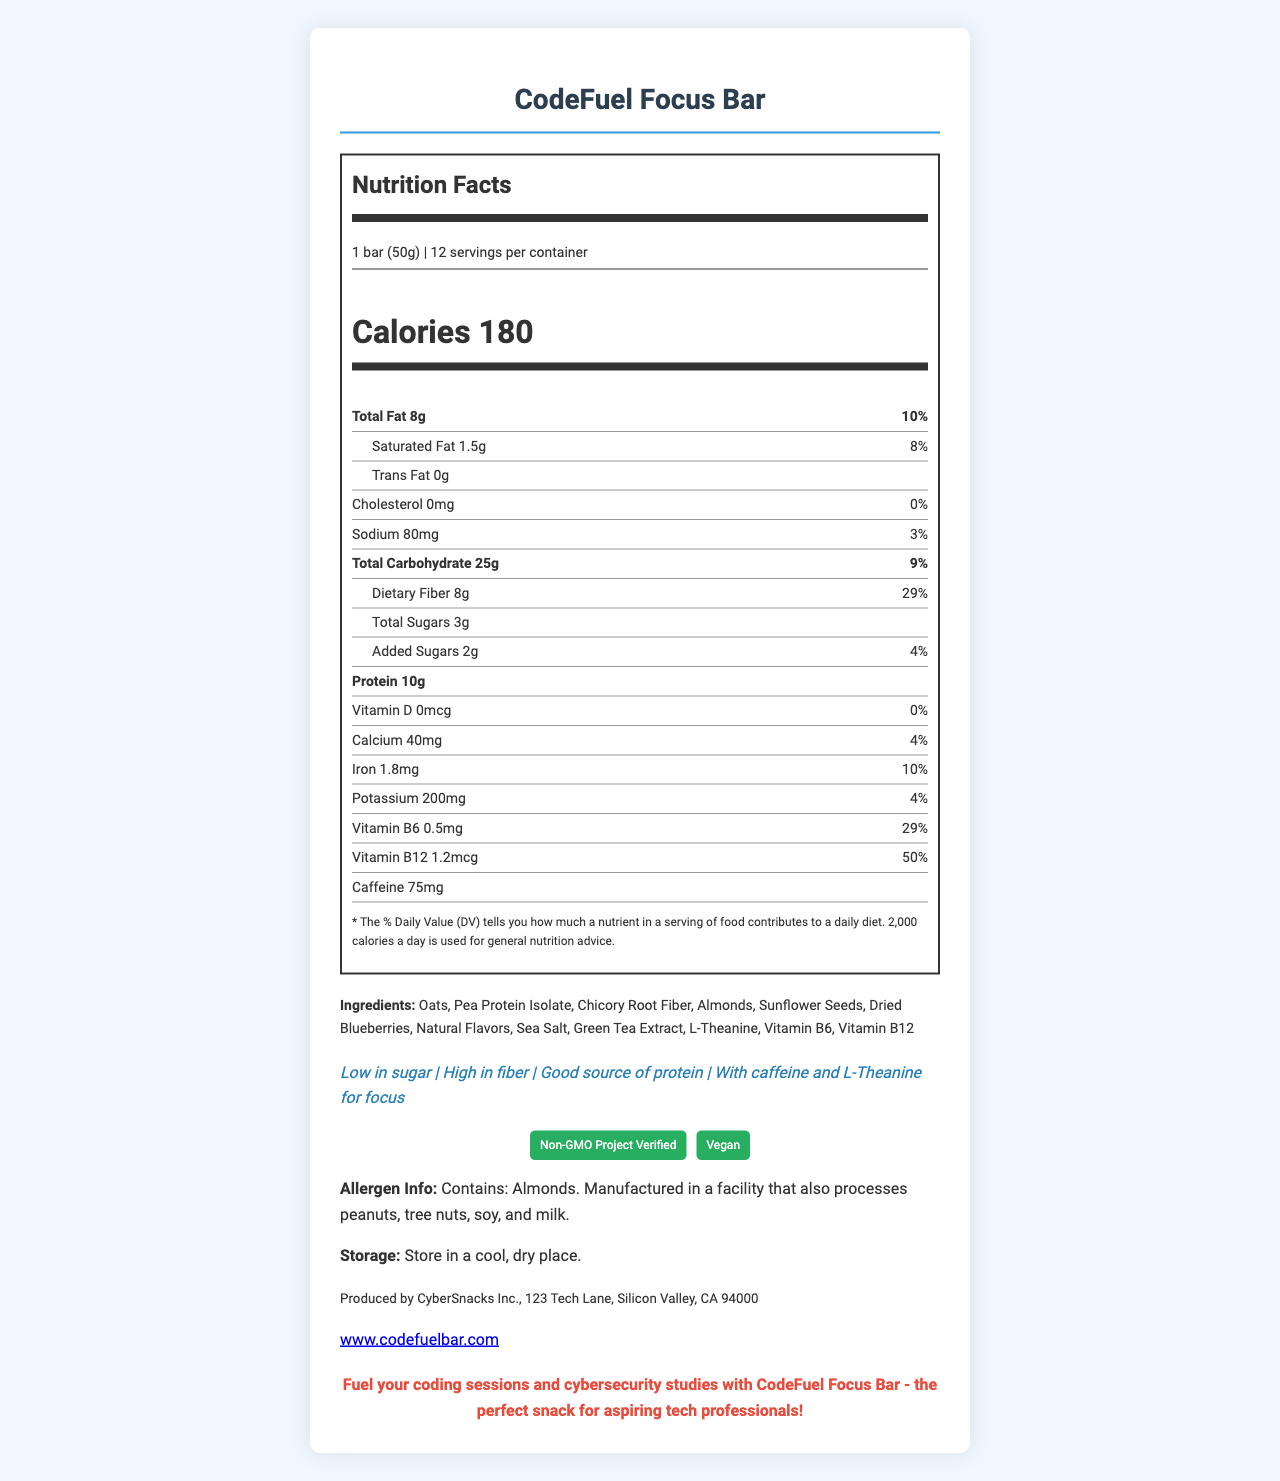what is the serving size? The serving size is stated at the beginning of the nutrition label under the "Serving Information" section.
Answer: 1 bar (50g) how many calories are in one serving? The number of calories per serving is highlighted in a larger font under the "Calories" section of the nutrition label.
Answer: 180 what is the total fat content in one serving? The total fat content is listed under the "Total Fat" section of the nutrition label.
Answer: 8g how much dietary fiber is in one serving? The amount of dietary fiber is listed under the "Dietary Fiber" section of the nutrition label.
Answer: 8g how much protein does one bar contain? The protein content is listed under the "Protein" section of the nutrition label.
Answer: 10g how many servings are there in one container? The number of servings per container is provided in the "Serving Information" section at the top of the nutrition label.
Answer: 12 which ingredient is not listed among the ingredients of the snack bar? A. Sea Salt B. Peanuts C. Green Tea Extract D. Natural Flavors The ingredients listed do not include peanuts; they do include sea salt, green tea extract, and natural flavors.
Answer: B what is the percentage daily value of vitamin B12 in one serving? A. 29% B. 50% C. 10% D. 8% The percentage daily value of vitamin B12 is listed as 50% in one serving.
Answer: B is the snack bar suitable for vegans? The certification section lists "Vegan," indicating that the product is suitable for vegans.
Answer: Yes does one serving of the snack bar contain cholesterol? The cholesterol section indicates "0mg" and "0%" daily value, meaning there is no cholesterol in one serving.
Answer: No describe the main idea of the document. The document contains a nutrition facts label, ingredient list, allergen information, claim statements, certifications, storage instructions, manufacturer details, and a custom message for the product.
Answer: The document provides detailed nutritional information about the "CodeFuel Focus Bar," including serving size, calories, and various nutrient contents. It highlights that the bar is low in sugar, high in fiber, and includes ingredients like oats, pea protein isolate, and green tea extract. The bar is designed to support focus and concentration during coding sessions and bears certifications such as "Non-GMO Project Verified" and "Vegan." what is the caffeine content of one serving? The caffeine content is listed as 75mg in the nutrition label.
Answer: 75mg how much sodium is in one serving? The sodium content is listed as 80mg in the nutrition label.
Answer: 80mg is the snack bar low in sugar? One of the claim statements lists "Low in sugar," indicating that the snack bar is low in sugar.
Answer: Yes which company produces the "CodeFuel Focus Bar"? The manufacturer information at the bottom of the document states that the product is produced by CyberSnacks Inc.
Answer: CyberSnacks Inc. which vitamin listed has the highest percentage daily value in one serving? Among the vitamins listed, Vitamin B12 has the highest percentage daily value at 50%.
Answer: Vitamin B12 does the document provide information on where the snack bar is manufactured? The manufacturer information section provides the address: "123 Tech Lane, Silicon Valley, CA 94000."
Answer: Yes what is the main claim related to the bar’s benefit for coding sessions? One of the claim statements says, "With caffeine and L-Theanine for focus," emphasizing the bar's benefit for focus during coding sessions.
Answer: With caffeine and L-Theanine for focus what should one do to store the bar properly? The storage instructions clearly state, "Store in a cool, dry place."
Answer: Store in a cool, dry place. how much vitamin D does one bar provide? The nutrition label lists the vitamin D content as 0mcg.
Answer: 0mcg what is the daily value percentage of saturated fat in one serving? The daily value percentage of saturated fat is listed as 8% in the nutrition label.
Answer: 8% which vitamin or mineral has a daily value percentage of 29%? Both Vitamin B6 and Dietary Fiber have a daily value percentage of 29%.
Answer: Vitamin B6 and Dietary Fiber is the snack bar non-GMO certified? One of the certifications listed is "Non-GMO Project Verified."
Answer: Yes does the allergen information state the presence of peanuts in the product? The allergen information mentions almonds and a facility that processes peanuts, tree nuts, soy, and milk, but does not state the presence of peanuts in the product itself.
Answer: No how many grams of added sugars are present in one serving? The nutrition label lists 2g of added sugars.
Answer: 2g do the ingredients include sunflower seeds? Sunflower seeds are listed among the ingredients.
Answer: Yes does the document specify the amount of trans fat in one serving? The trans fat content is listed as 0g.
Answer: Yes 